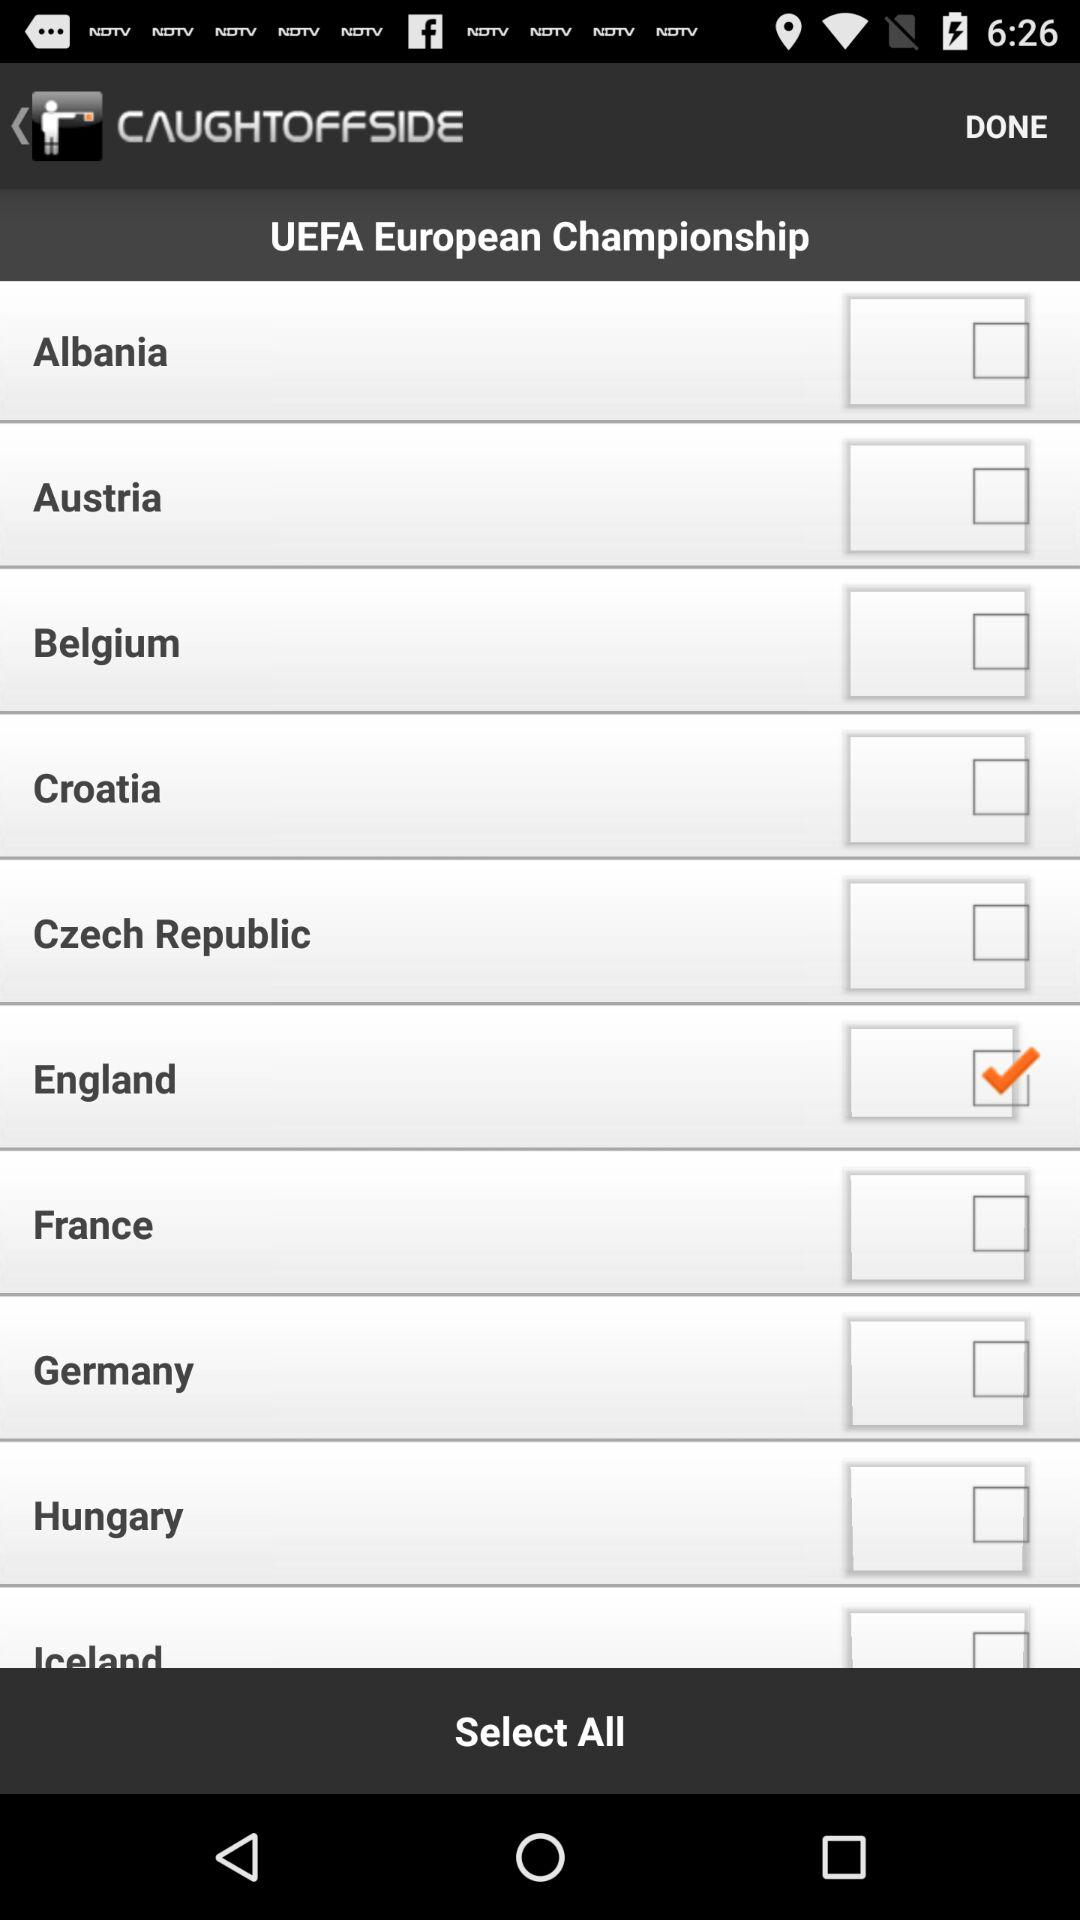Which are the different options? The different options are "Albania", "Austria", "Belgium", "Croatia", "Czech Republic", "England", "France", "Germany", "Hungary" and "Iceland". 